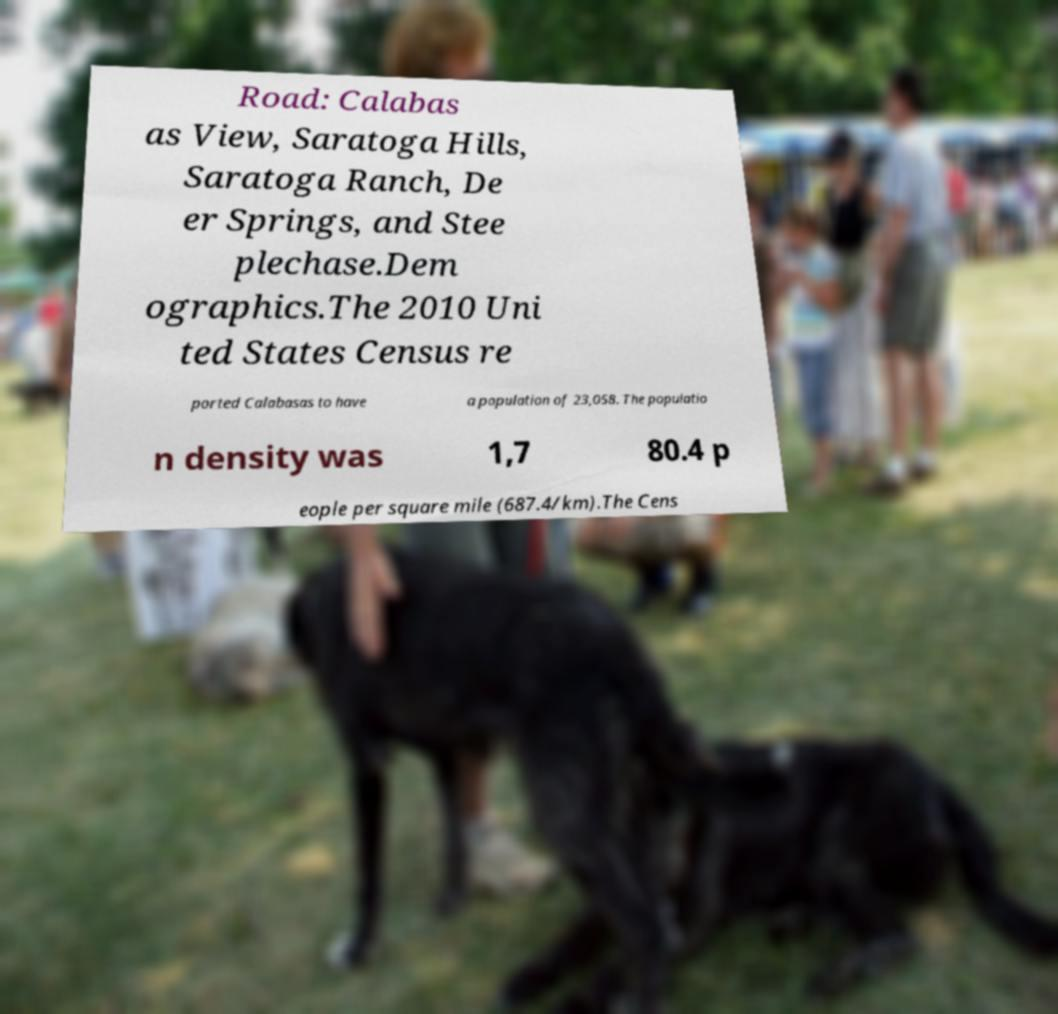Can you read and provide the text displayed in the image?This photo seems to have some interesting text. Can you extract and type it out for me? Road: Calabas as View, Saratoga Hills, Saratoga Ranch, De er Springs, and Stee plechase.Dem ographics.The 2010 Uni ted States Census re ported Calabasas to have a population of 23,058. The populatio n density was 1,7 80.4 p eople per square mile (687.4/km).The Cens 